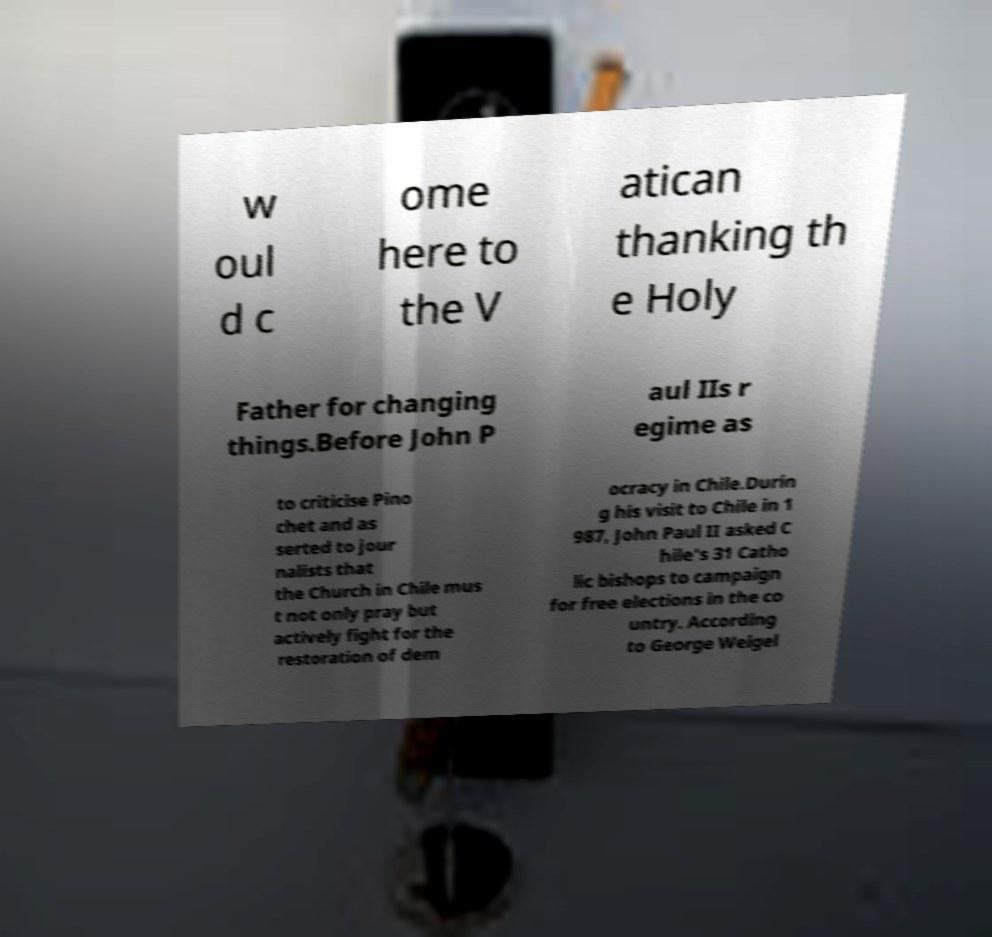Please read and relay the text visible in this image. What does it say? w oul d c ome here to the V atican thanking th e Holy Father for changing things.Before John P aul IIs r egime as to criticise Pino chet and as serted to jour nalists that the Church in Chile mus t not only pray but actively fight for the restoration of dem ocracy in Chile.Durin g his visit to Chile in 1 987, John Paul II asked C hile's 31 Catho lic bishops to campaign for free elections in the co untry. According to George Weigel 